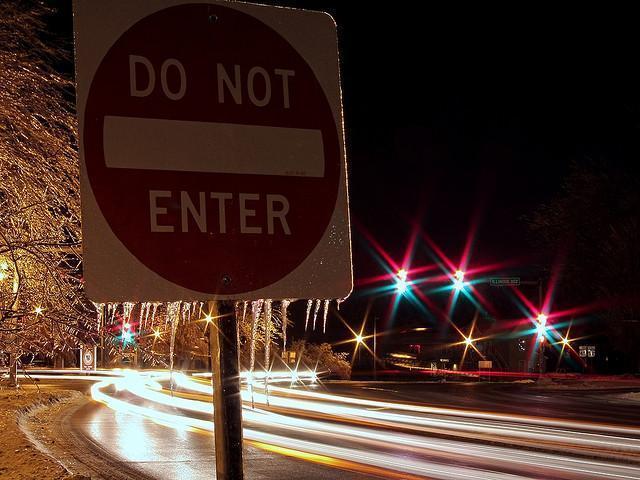How many bananas are visible?
Give a very brief answer. 0. 